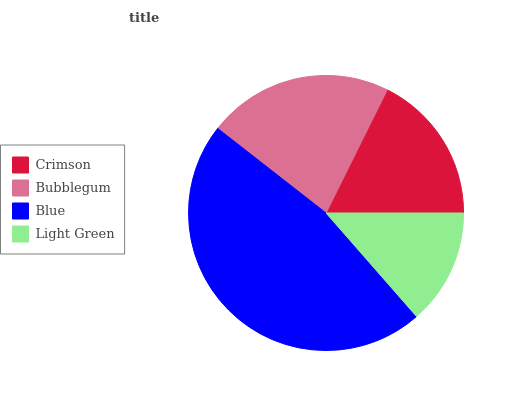Is Light Green the minimum?
Answer yes or no. Yes. Is Blue the maximum?
Answer yes or no. Yes. Is Bubblegum the minimum?
Answer yes or no. No. Is Bubblegum the maximum?
Answer yes or no. No. Is Bubblegum greater than Crimson?
Answer yes or no. Yes. Is Crimson less than Bubblegum?
Answer yes or no. Yes. Is Crimson greater than Bubblegum?
Answer yes or no. No. Is Bubblegum less than Crimson?
Answer yes or no. No. Is Bubblegum the high median?
Answer yes or no. Yes. Is Crimson the low median?
Answer yes or no. Yes. Is Blue the high median?
Answer yes or no. No. Is Blue the low median?
Answer yes or no. No. 